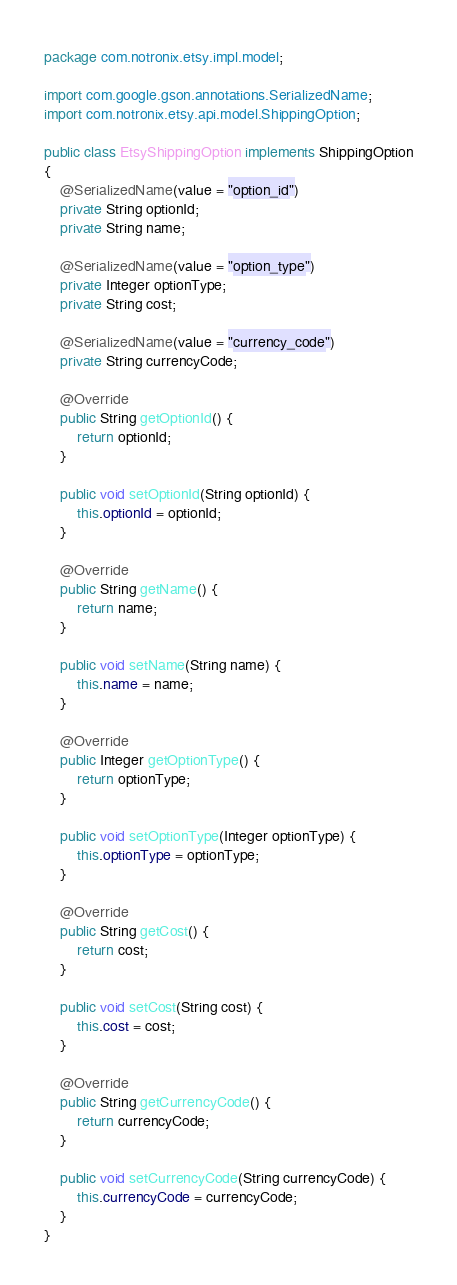<code> <loc_0><loc_0><loc_500><loc_500><_Java_>package com.notronix.etsy.impl.model;

import com.google.gson.annotations.SerializedName;
import com.notronix.etsy.api.model.ShippingOption;

public class EtsyShippingOption implements ShippingOption
{
    @SerializedName(value = "option_id")
    private String optionId;
    private String name;

    @SerializedName(value = "option_type")
    private Integer optionType;
    private String cost;

    @SerializedName(value = "currency_code")
    private String currencyCode;

    @Override
    public String getOptionId() {
        return optionId;
    }

    public void setOptionId(String optionId) {
        this.optionId = optionId;
    }

    @Override
    public String getName() {
        return name;
    }

    public void setName(String name) {
        this.name = name;
    }

    @Override
    public Integer getOptionType() {
        return optionType;
    }

    public void setOptionType(Integer optionType) {
        this.optionType = optionType;
    }

    @Override
    public String getCost() {
        return cost;
    }

    public void setCost(String cost) {
        this.cost = cost;
    }

    @Override
    public String getCurrencyCode() {
        return currencyCode;
    }

    public void setCurrencyCode(String currencyCode) {
        this.currencyCode = currencyCode;
    }
}
</code> 